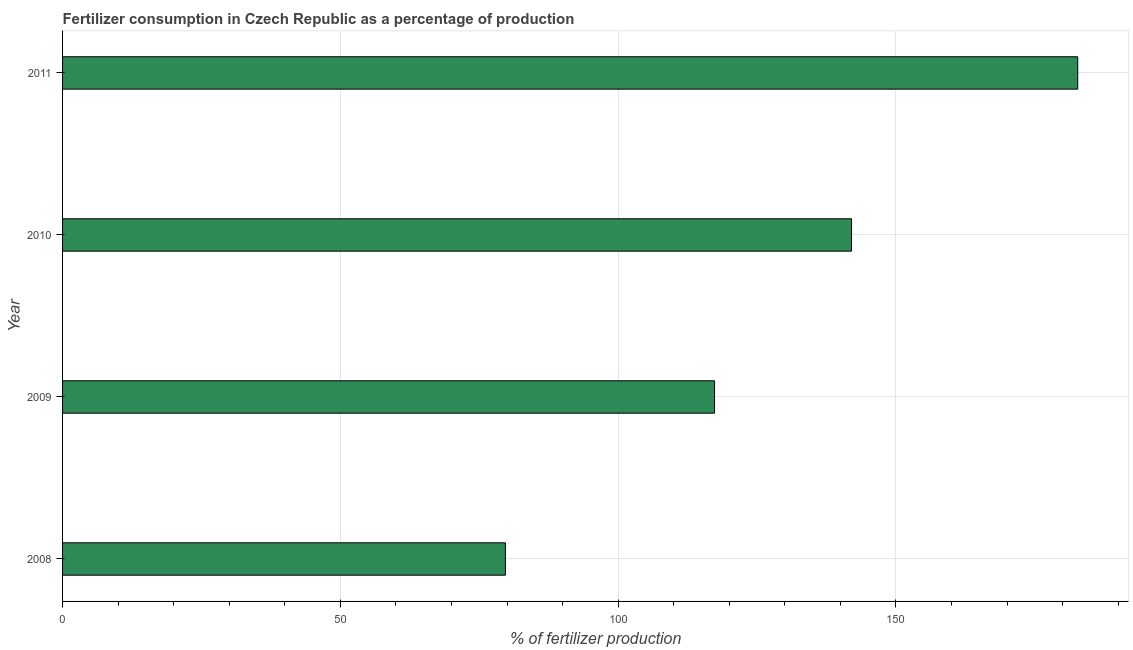Does the graph contain grids?
Give a very brief answer. Yes. What is the title of the graph?
Ensure brevity in your answer.  Fertilizer consumption in Czech Republic as a percentage of production. What is the label or title of the X-axis?
Offer a very short reply. % of fertilizer production. What is the amount of fertilizer consumption in 2008?
Offer a very short reply. 79.71. Across all years, what is the maximum amount of fertilizer consumption?
Your response must be concise. 182.73. Across all years, what is the minimum amount of fertilizer consumption?
Ensure brevity in your answer.  79.71. In which year was the amount of fertilizer consumption maximum?
Your answer should be very brief. 2011. What is the sum of the amount of fertilizer consumption?
Your answer should be compact. 521.82. What is the difference between the amount of fertilizer consumption in 2010 and 2011?
Your answer should be very brief. -40.71. What is the average amount of fertilizer consumption per year?
Give a very brief answer. 130.46. What is the median amount of fertilizer consumption?
Give a very brief answer. 129.69. In how many years, is the amount of fertilizer consumption greater than 130 %?
Keep it short and to the point. 2. Do a majority of the years between 2011 and 2010 (inclusive) have amount of fertilizer consumption greater than 120 %?
Your answer should be very brief. No. What is the ratio of the amount of fertilizer consumption in 2009 to that in 2011?
Make the answer very short. 0.64. Is the difference between the amount of fertilizer consumption in 2008 and 2010 greater than the difference between any two years?
Give a very brief answer. No. What is the difference between the highest and the second highest amount of fertilizer consumption?
Provide a succinct answer. 40.71. Is the sum of the amount of fertilizer consumption in 2008 and 2011 greater than the maximum amount of fertilizer consumption across all years?
Your answer should be very brief. Yes. What is the difference between the highest and the lowest amount of fertilizer consumption?
Offer a very short reply. 103.02. Are all the bars in the graph horizontal?
Make the answer very short. Yes. How many years are there in the graph?
Your answer should be very brief. 4. What is the % of fertilizer production of 2008?
Provide a short and direct response. 79.71. What is the % of fertilizer production of 2009?
Your answer should be very brief. 117.36. What is the % of fertilizer production in 2010?
Keep it short and to the point. 142.02. What is the % of fertilizer production in 2011?
Keep it short and to the point. 182.73. What is the difference between the % of fertilizer production in 2008 and 2009?
Offer a terse response. -37.64. What is the difference between the % of fertilizer production in 2008 and 2010?
Your answer should be compact. -62.31. What is the difference between the % of fertilizer production in 2008 and 2011?
Provide a short and direct response. -103.02. What is the difference between the % of fertilizer production in 2009 and 2010?
Offer a very short reply. -24.66. What is the difference between the % of fertilizer production in 2009 and 2011?
Your response must be concise. -65.38. What is the difference between the % of fertilizer production in 2010 and 2011?
Make the answer very short. -40.71. What is the ratio of the % of fertilizer production in 2008 to that in 2009?
Make the answer very short. 0.68. What is the ratio of the % of fertilizer production in 2008 to that in 2010?
Make the answer very short. 0.56. What is the ratio of the % of fertilizer production in 2008 to that in 2011?
Your answer should be very brief. 0.44. What is the ratio of the % of fertilizer production in 2009 to that in 2010?
Ensure brevity in your answer.  0.83. What is the ratio of the % of fertilizer production in 2009 to that in 2011?
Provide a short and direct response. 0.64. What is the ratio of the % of fertilizer production in 2010 to that in 2011?
Ensure brevity in your answer.  0.78. 